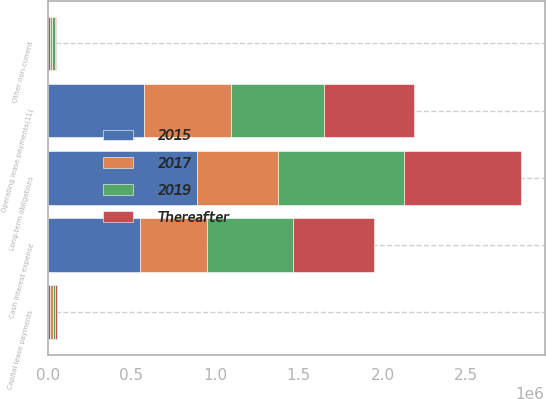Convert chart to OTSL. <chart><loc_0><loc_0><loc_500><loc_500><stacked_bar_chart><ecel><fcel>Long-term obligations<fcel>Cash interest expense<fcel>Capital lease payments<fcel>Operating lease payments(11)<fcel>Other non-current<nl><fcel>2015<fcel>888810<fcel>550000<fcel>15589<fcel>574438<fcel>11082<nl><fcel>2019<fcel>753045<fcel>517000<fcel>14049<fcel>553864<fcel>20480<nl><fcel>Thereafter<fcel>700608<fcel>485000<fcel>12905<fcel>538405<fcel>5705<nl><fcel>2017<fcel>485000<fcel>399000<fcel>12456<fcel>519034<fcel>13911<nl></chart> 